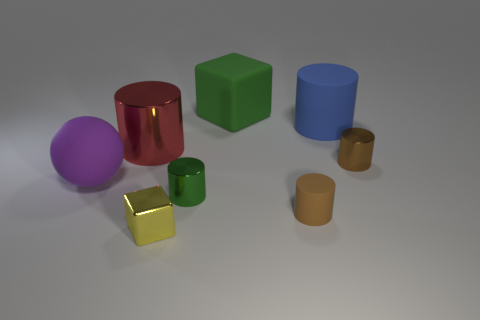Is there any other thing of the same color as the small shiny cube?
Give a very brief answer. No. The blue rubber object has what shape?
Provide a succinct answer. Cylinder. What color is the shiny cube that is the same size as the green metal object?
Ensure brevity in your answer.  Yellow. How many blue objects are either metal cubes or big rubber cylinders?
Provide a succinct answer. 1. Are there more green matte cubes than big green spheres?
Offer a very short reply. Yes. There is a brown cylinder behind the small green object; is its size the same as the brown object that is on the left side of the blue rubber thing?
Make the answer very short. Yes. What is the color of the large cylinder on the right side of the metal cylinder that is to the left of the green metal object right of the red shiny cylinder?
Your answer should be very brief. Blue. Are there any big brown shiny objects that have the same shape as the big green object?
Offer a very short reply. No. Is the number of small metallic cylinders that are behind the purple matte sphere greater than the number of big gray metallic objects?
Keep it short and to the point. Yes. How many rubber objects are large objects or blue cylinders?
Your response must be concise. 3. 